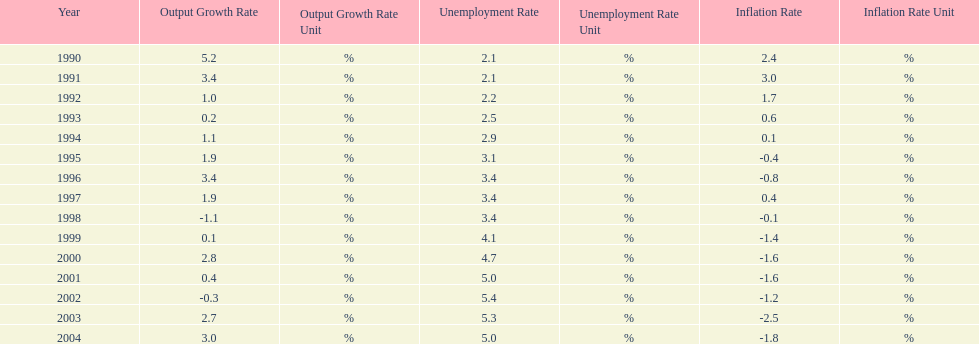Were the highest unemployment rates in japan before or after the year 2000? After. 